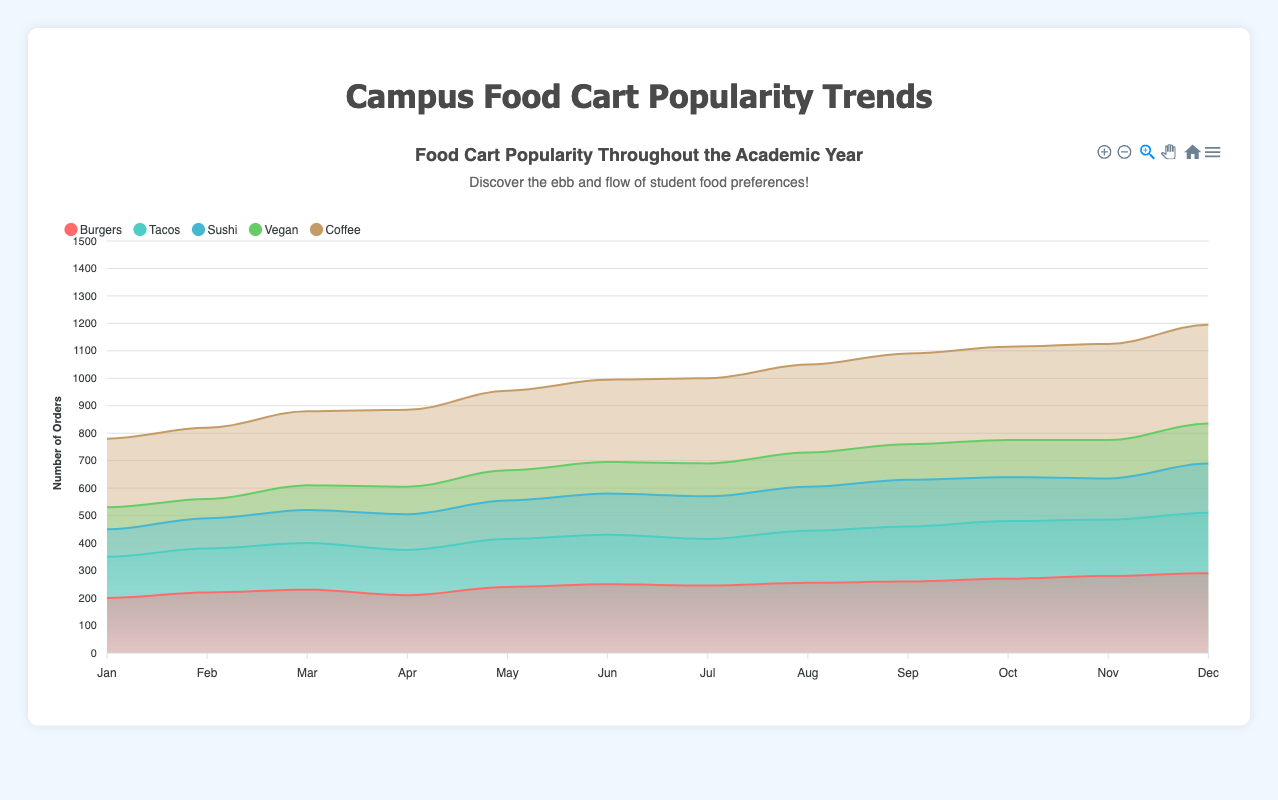What are the top two most popular food categories in January? Refer to the January data point on the chart, identify that coffee and burgers had the highest number of orders. Coffee had 250 orders and burgers had 200.
Answer: Coffee and Burgers Which month saw the highest number of sushi orders? Look at the sushi line in the area chart and notice that December had the highest peak.
Answer: December What is the trend for vegan orders over the year? Observe the vegan area in the chart starting from January to December. It shows a general increasing trend from 80 orders in January to 145 orders in December.
Answer: Increasing How does the popularity of burgers compare to tacos in June? Check the values for June; burgers had 250 orders, and tacos had 180 orders. Burgers were more popular.
Answer: Burgers were more popular Which food category had the most consistent growth over the academic year? Analyze the trend of each category over the months. Coffee showed the most consistent growth with incremental increases every month from 250 in January to 360 in December.
Answer: Coffee When did tacos see the largest monthly increase in orders? Compare the month-to-month changes in the tacos area. The largest jump was from July (170) to August (190), which is an increase of 20 orders.
Answer: July to August What is the total number of burgers and sushi orders in the first quarter (January to March)? Sum up the orders for burgers (200+220+230) and sushi (100+110+120) from January to March. Burgers: 650, Sushi: 330, Total: 980 orders.
Answer: 980 orders In which months did vegan orders surpass taco orders? Compare the vegan and taco areas in each month. The only month where vegan orders (80) surpassed taco orders (70) was in February.
Answer: February What's the difference in the number of coffee orders between September and December? Look at the chart for coffee in September (330) and December (360). The difference is 360 - 330 = 30 orders.
Answer: 30 Which two food categories had close orders in October? Check the other categories besides the one leading in October, which are sushi (160) and tacos (210), looking for close values. None of them are very close, with at least a 50+ difference. Check for another close set. Vegan (135) and sushi (160) might appear relatively close but aren't under the same axis step. Hence, there are no close valued sets visible following main axis values.
Answer: N/A 